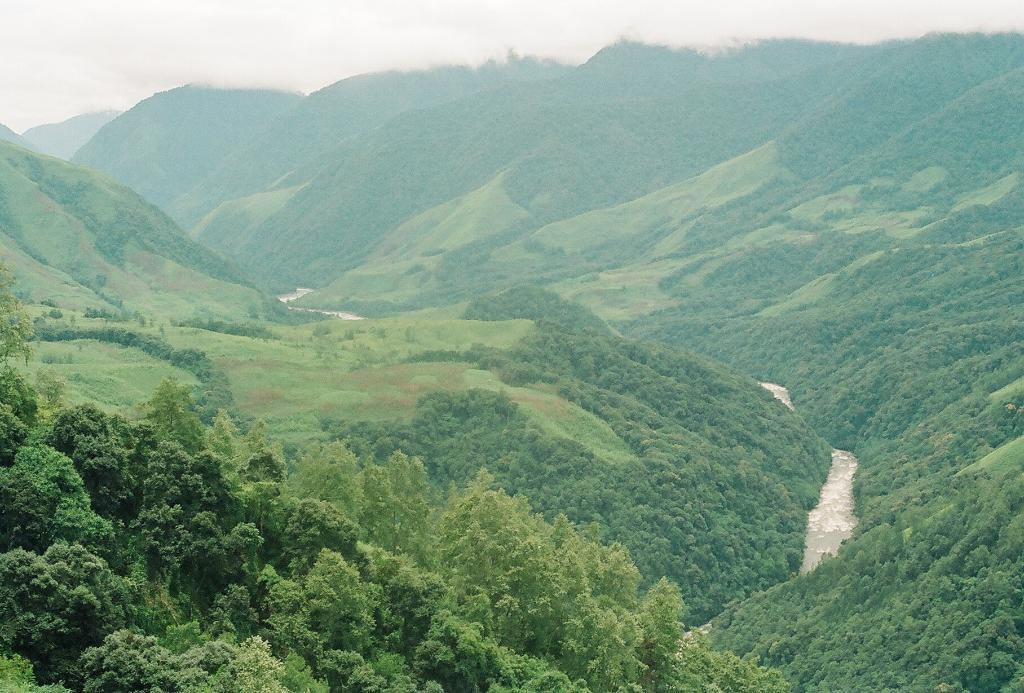What type of vegetation can be seen in the foreground of the image? There is greenery in the foreground of the image. What natural features are visible in the background of the image? Mountains and the sky are visible in the background of the image. Is there any indication of a path or trail in the image? Yes, there appears to be a path on the right side of the image. How many clams can be seen on the path in the image? There are no clams present in the image; the path is surrounded by greenery and mountains. What decision is being made by the mountains in the image? The mountains are not making any decisions; they are a natural feature in the background of the image. 